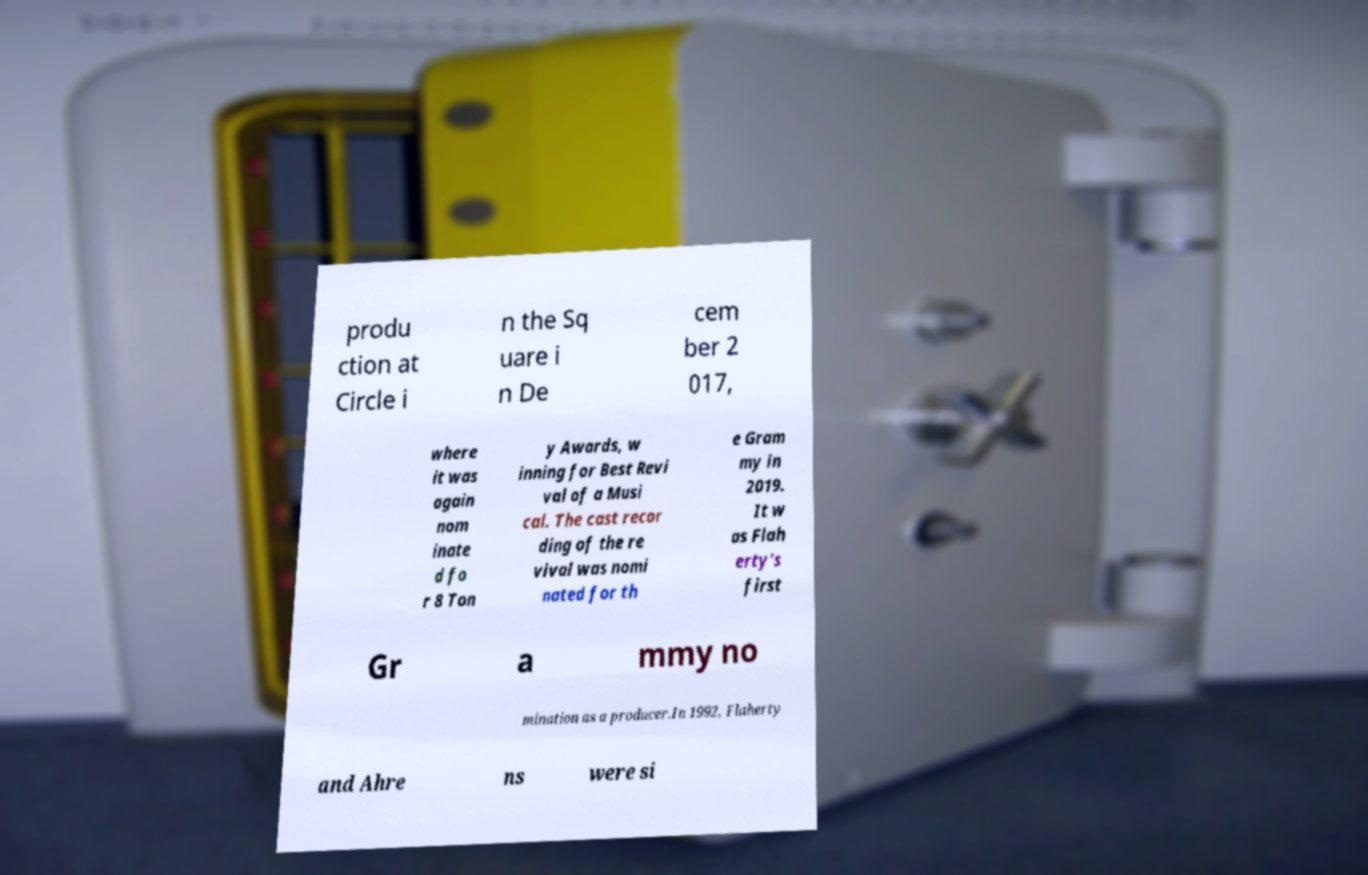I need the written content from this picture converted into text. Can you do that? produ ction at Circle i n the Sq uare i n De cem ber 2 017, where it was again nom inate d fo r 8 Ton y Awards, w inning for Best Revi val of a Musi cal. The cast recor ding of the re vival was nomi nated for th e Gram my in 2019. It w as Flah erty's first Gr a mmy no mination as a producer.In 1992, Flaherty and Ahre ns were si 